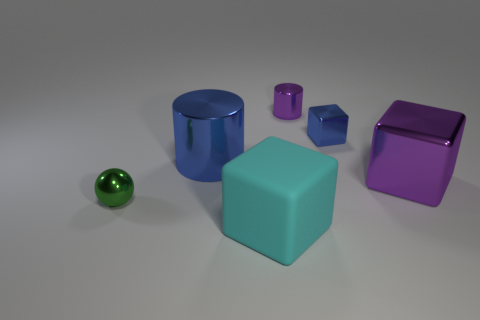What size is the purple metal object right of the metal object that is behind the small block? The purple metal object to the right of the metal cylinder, which is behind the small blue block, is large in size, particularly in comparison to the adjacent blocks and the small metal object closer to the foreground. 